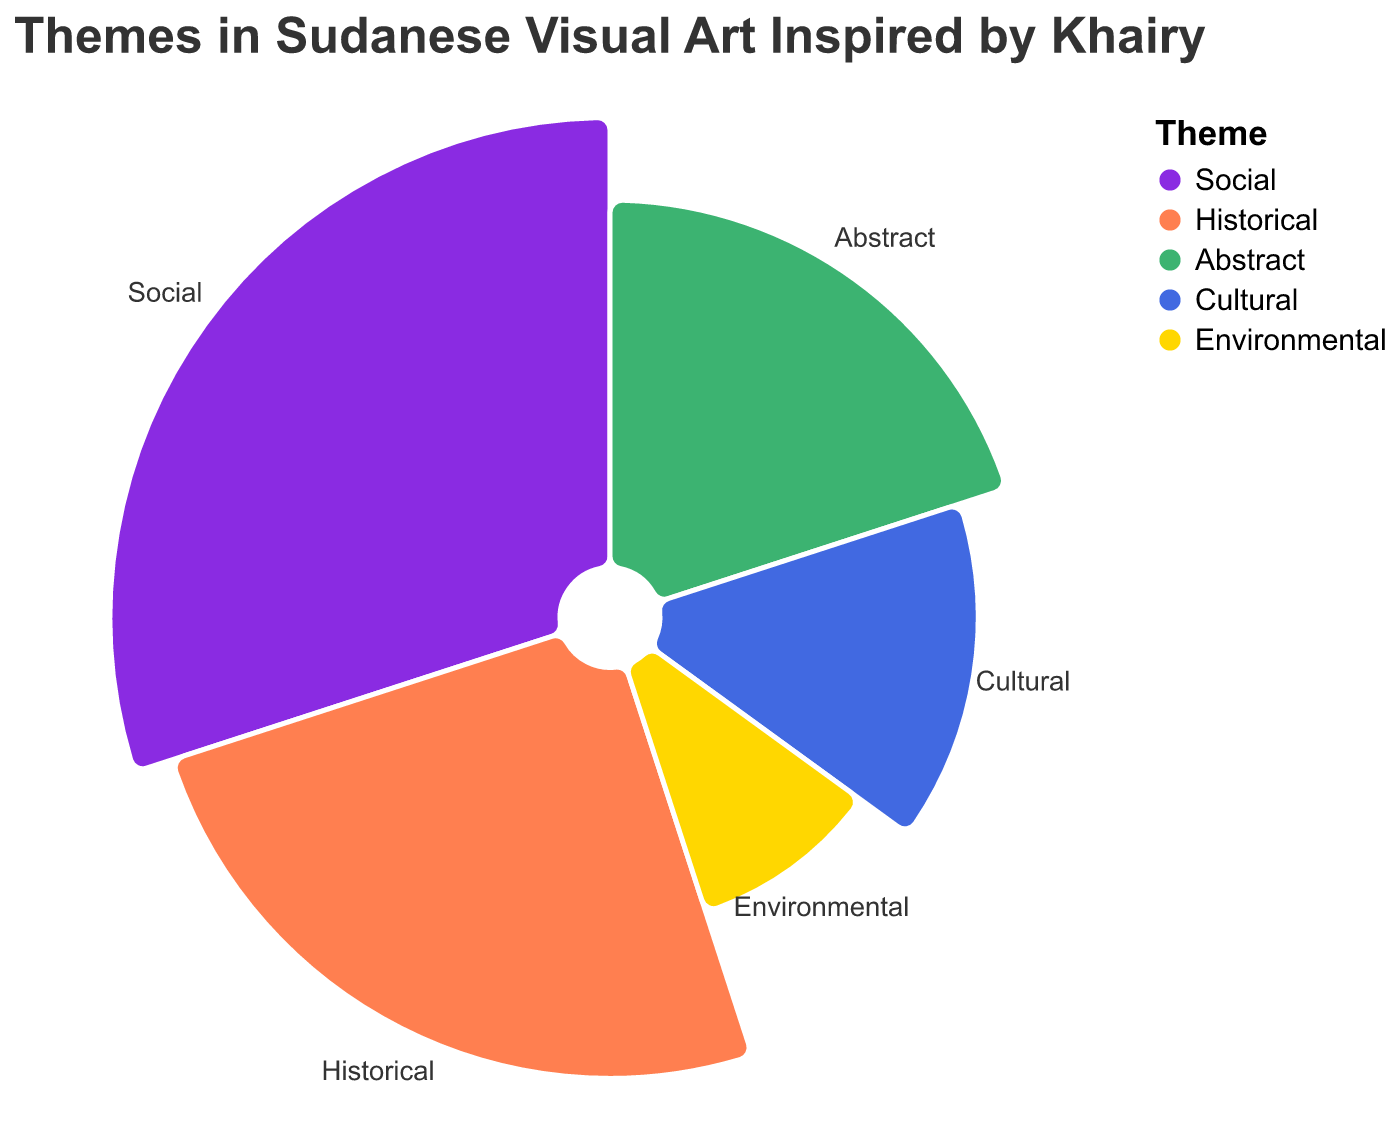What is the title of the figure? The title is usually prominently displayed at the top of the figure in a larger font.
Answer: Themes in Sudanese Visual Art Inspired by Khairy Which theme has the highest proportion? The figure's various segments with different colors represent the themes. The largest arc segment corresponds to the highest proportion.
Answer: Social What proportion of the themes is represented by Historical and Abstract together? The proportions are shown within the segments of the figure. By simply adding the proportions of Historical (25) and Abstract (20), we get 45.
Answer: 45% How does the proportion of Environmental compare to Cultural? To compare, observe the corresponding segments in the figure. Environmental has a proportion of 10 while Cultural has 15.
Answer: Cultural has a higher proportion than Environmental What colors are associated with the Abstract and Cultural themes? Each theme is shown in a distinct color. Abstract and Cultural themes correspond to two different segments. Abstract is green, and Cultural is royal blue.
Answer: Green and Royal Blue Which theme has the smallest proportion, and what is that proportion? By inspecting the sizes of the segments in the figure, the smallest arc segment represents the smallest proportion. The Environmental theme has the smallest proportion.
Answer: Environmental, 10% Is the combination of Social and Environmental themes greater than 50%? Sum the proportions of Social (30) and Environmental (10). The total is 40, which is less than 50%.
Answer: No How diverse are the themes in the figure in terms of proportional distribution? By looking at the figure, we observe a color-coded spread of themes, with proportions ranging from 10 to 30.
Answer: Diverse, spread from 10% to 30% What is the average proportion of all themes? Calculate the total proportion by adding 30, 25, 20, 15, and 10, which equals 100. There are 5 themes, so the average is 100/5.
Answer: 20% Which theme’s proportion is exactly midway between the highest and lowest proportions? The highest proportion is Social (30) and the lowest is Environmental (10). The midpoint is (30+10)/2 = 20, which corresponds to Abstract.
Answer: Abstract 